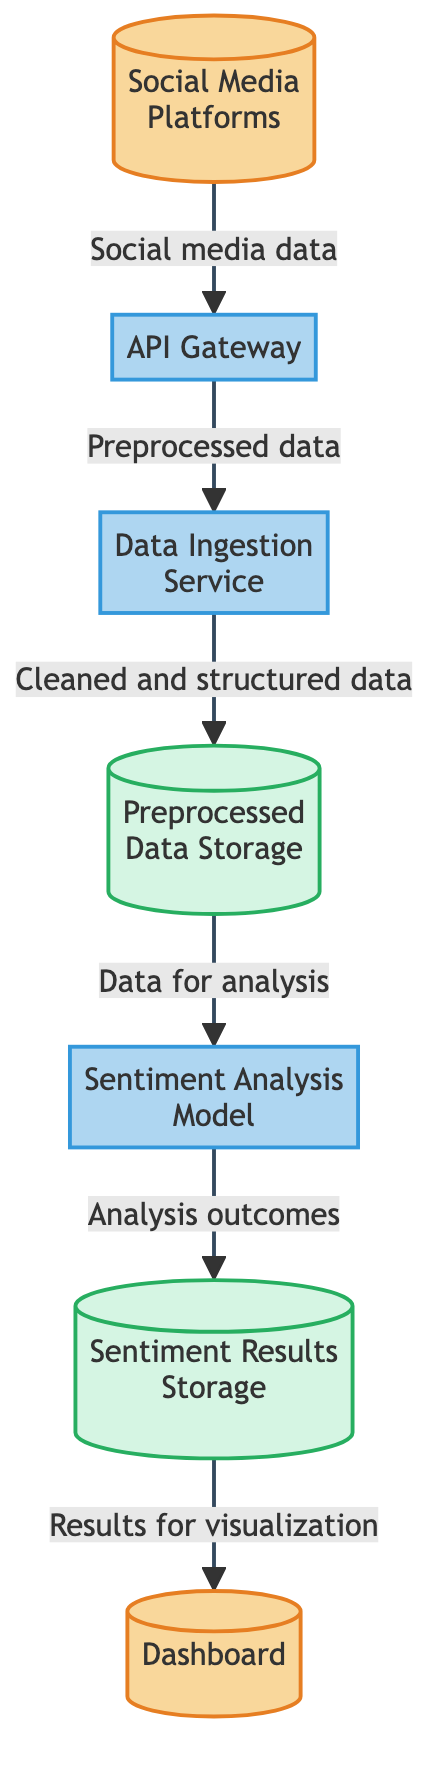What type of entity is "Social Media Platforms"? The diagram classifies "Social Media Platforms" as an external entity, as indicated by its color coding and label.
Answer: external entity How many processes are present in the diagram? By counting the labeled nodes, there are four processes: API Gateway, Data Ingestion Service, Sentiment Analysis Model.
Answer: 3 What data flows from "API Gateway" to "Data Ingestion Service"? The labeled flow indicates that "Preprocessed data" is transferred from "API Gateway" to "Data Ingestion Service."
Answer: Preprocessed data What is stored in "Preprocessed Data Storage"? The diagram specifies that "Cleaned and structured data" is stored in "Preprocessed Data Storage."
Answer: Cleaned and structured data What is the output of the "Sentiment Analysis Model"? The output shown in the diagram indicates that the "Sentiment Analysis Model" produces "Analysis outcomes" which are stored in "Sentiment Results Storage."
Answer: Analysis outcomes What is the final output destination in the diagram? The final flow connects "Sentiment Results Storage" to "Dashboard" indicating that it serves as the visualization interface for the results.
Answer: Dashboard How many external entities are shown in the diagram? Counting the nodes labeled as external entities, there are two: "Social Media Platforms" and "Dashboard."
Answer: 2 What is the purpose of the "API Gateway"? "API Gateway" is described as facilitating communication between social media platforms and the data ingestion service, which is its main function stated in the diagram.
Answer: Facilitates communication What is the flow of data after it is cleaned and structured? After cleaning and structuring, the data is stored in "Preprocessed Data Storage" and then flows to the "Sentiment Analysis Model" for further analysis.
Answer: To the Sentiment Analysis Model 